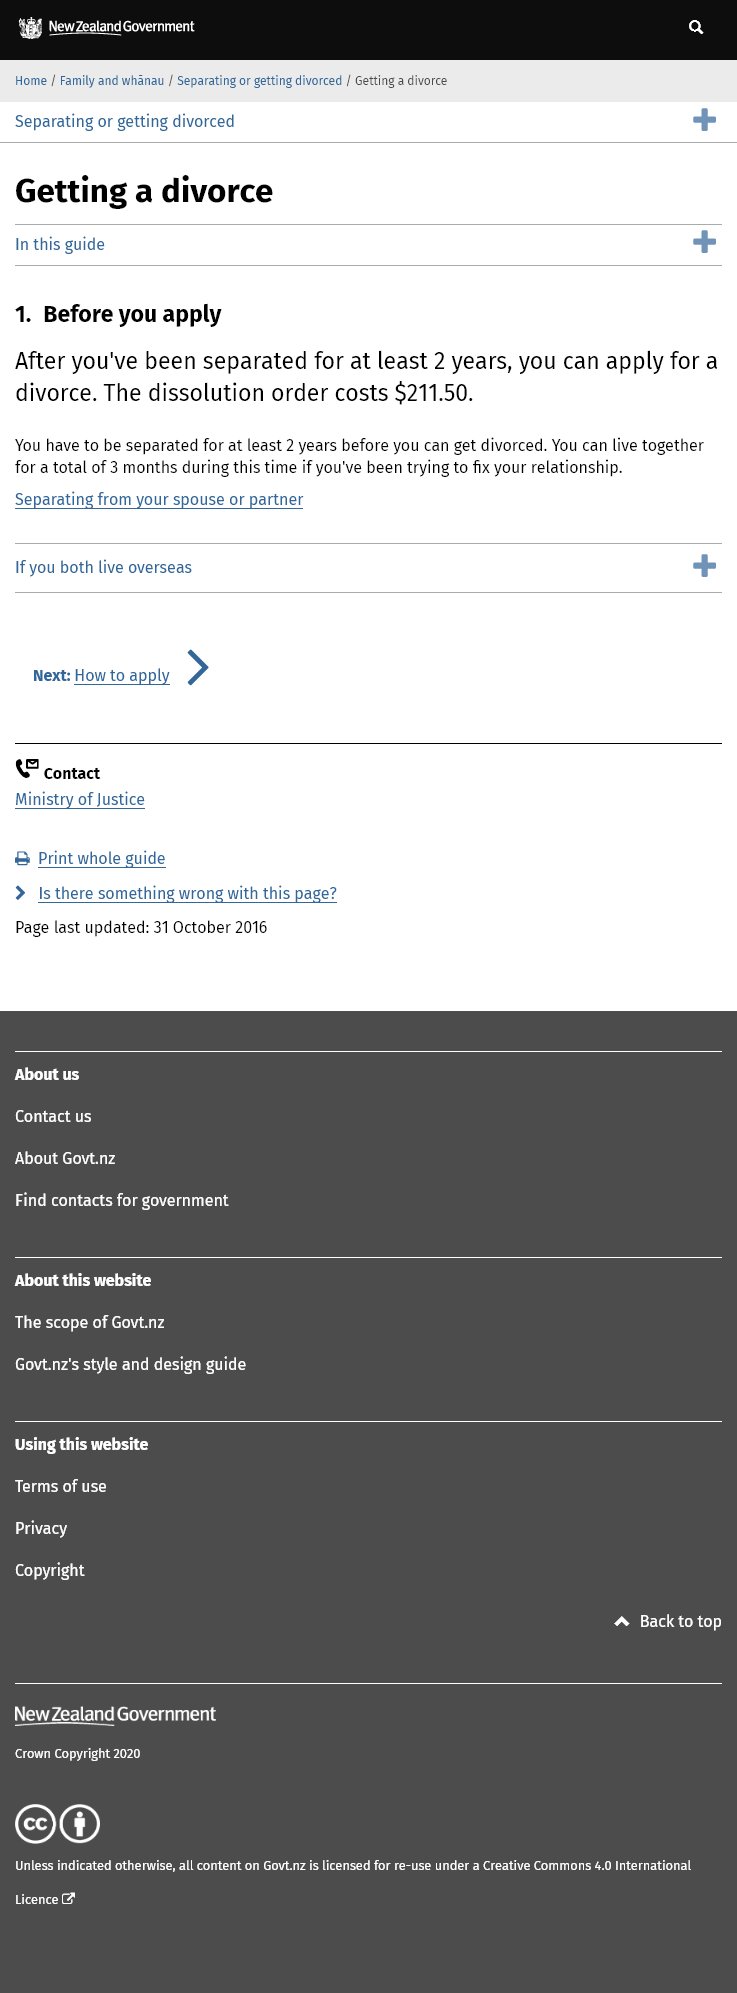Indicate a few pertinent items in this graphic. It is necessary to have been separated for a minimum of 2 years before applying for a divorce, as stated. The cost of a dissolution order is $211.50 as stated. It is necessary to live with your partner for a period of 3 months if one is seeking to repair the relationship. 